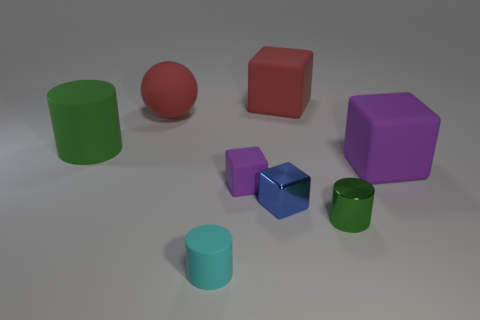Subtract all matte cubes. How many cubes are left? 1 Add 1 cyan balls. How many objects exist? 9 Subtract all blue blocks. How many blocks are left? 3 Subtract all spheres. How many objects are left? 7 Subtract 1 spheres. How many spheres are left? 0 Subtract 0 brown spheres. How many objects are left? 8 Subtract all cyan balls. Subtract all cyan cylinders. How many balls are left? 1 Subtract all green spheres. How many green cylinders are left? 2 Subtract all small blue cylinders. Subtract all blue metal things. How many objects are left? 7 Add 6 cyan matte objects. How many cyan matte objects are left? 7 